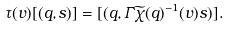<formula> <loc_0><loc_0><loc_500><loc_500>\tau ( v ) [ ( q , s ) ] = [ ( q , \varGamma \widetilde { \chi } ( q ) ^ { - 1 } ( v ) s ) ] .</formula> 